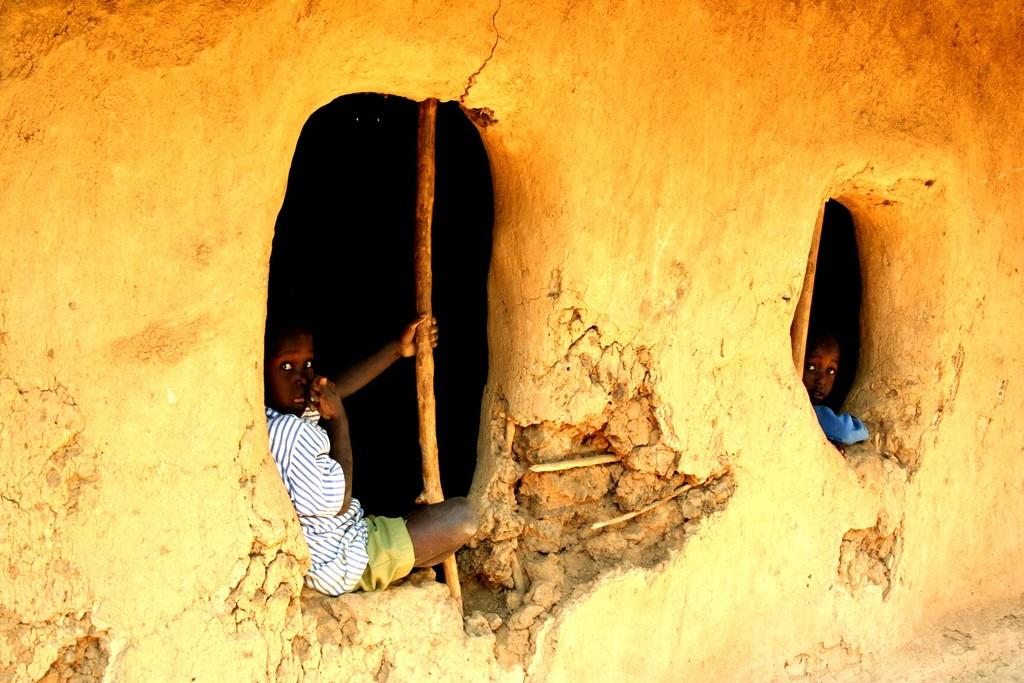Who is present in the image? There are children in the image. What can be seen in the image besides the children? There is a hole and a wall in the image. What type of bun is the grandmother holding in the image? There is no grandmother or bun present in the image. What card game are the children playing in the image? There is no card game or cards visible in the image. 